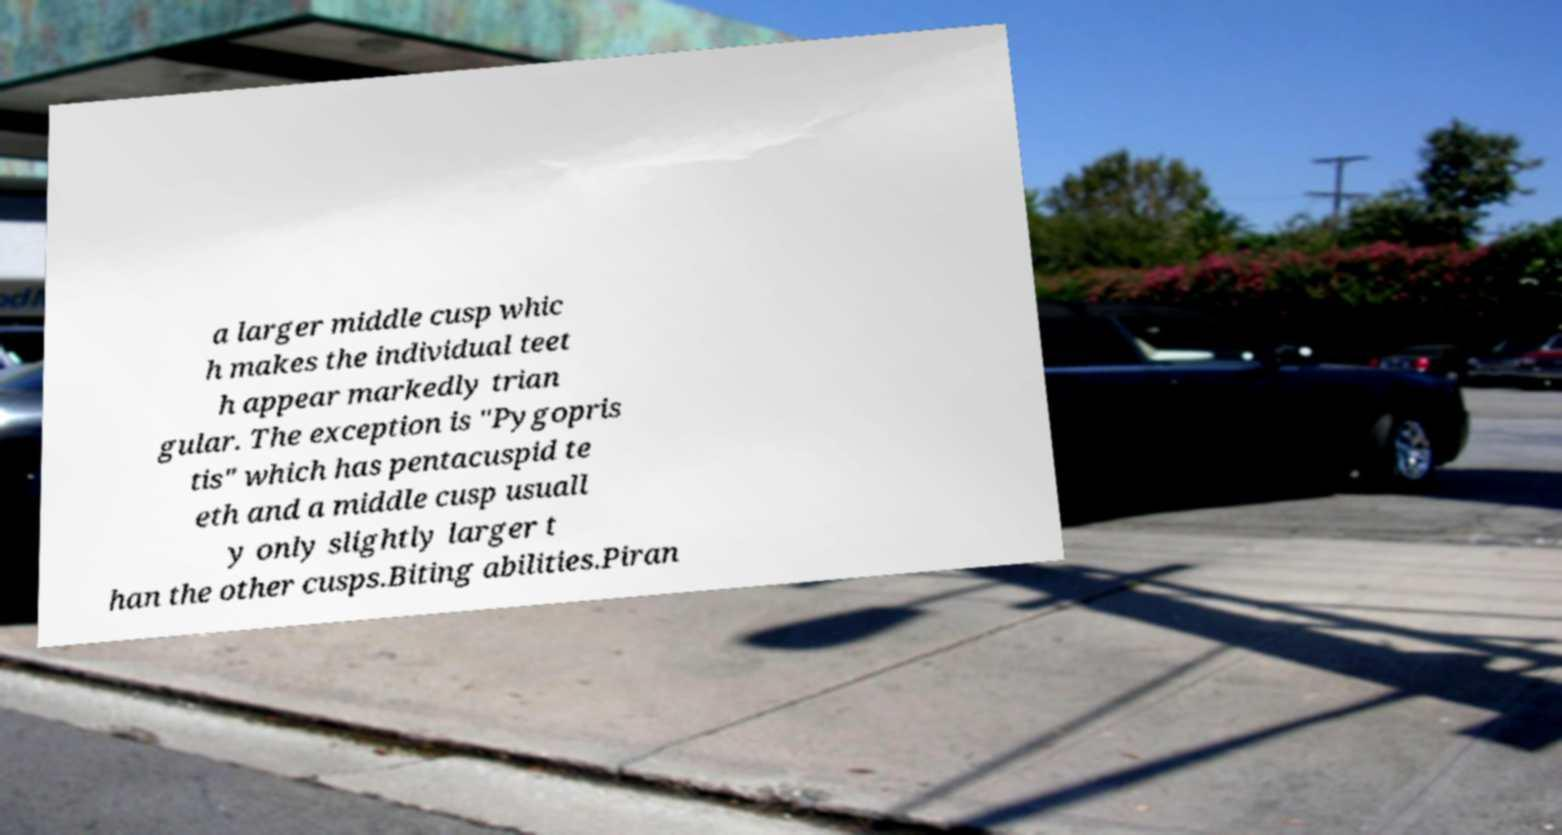Could you assist in decoding the text presented in this image and type it out clearly? a larger middle cusp whic h makes the individual teet h appear markedly trian gular. The exception is "Pygopris tis" which has pentacuspid te eth and a middle cusp usuall y only slightly larger t han the other cusps.Biting abilities.Piran 